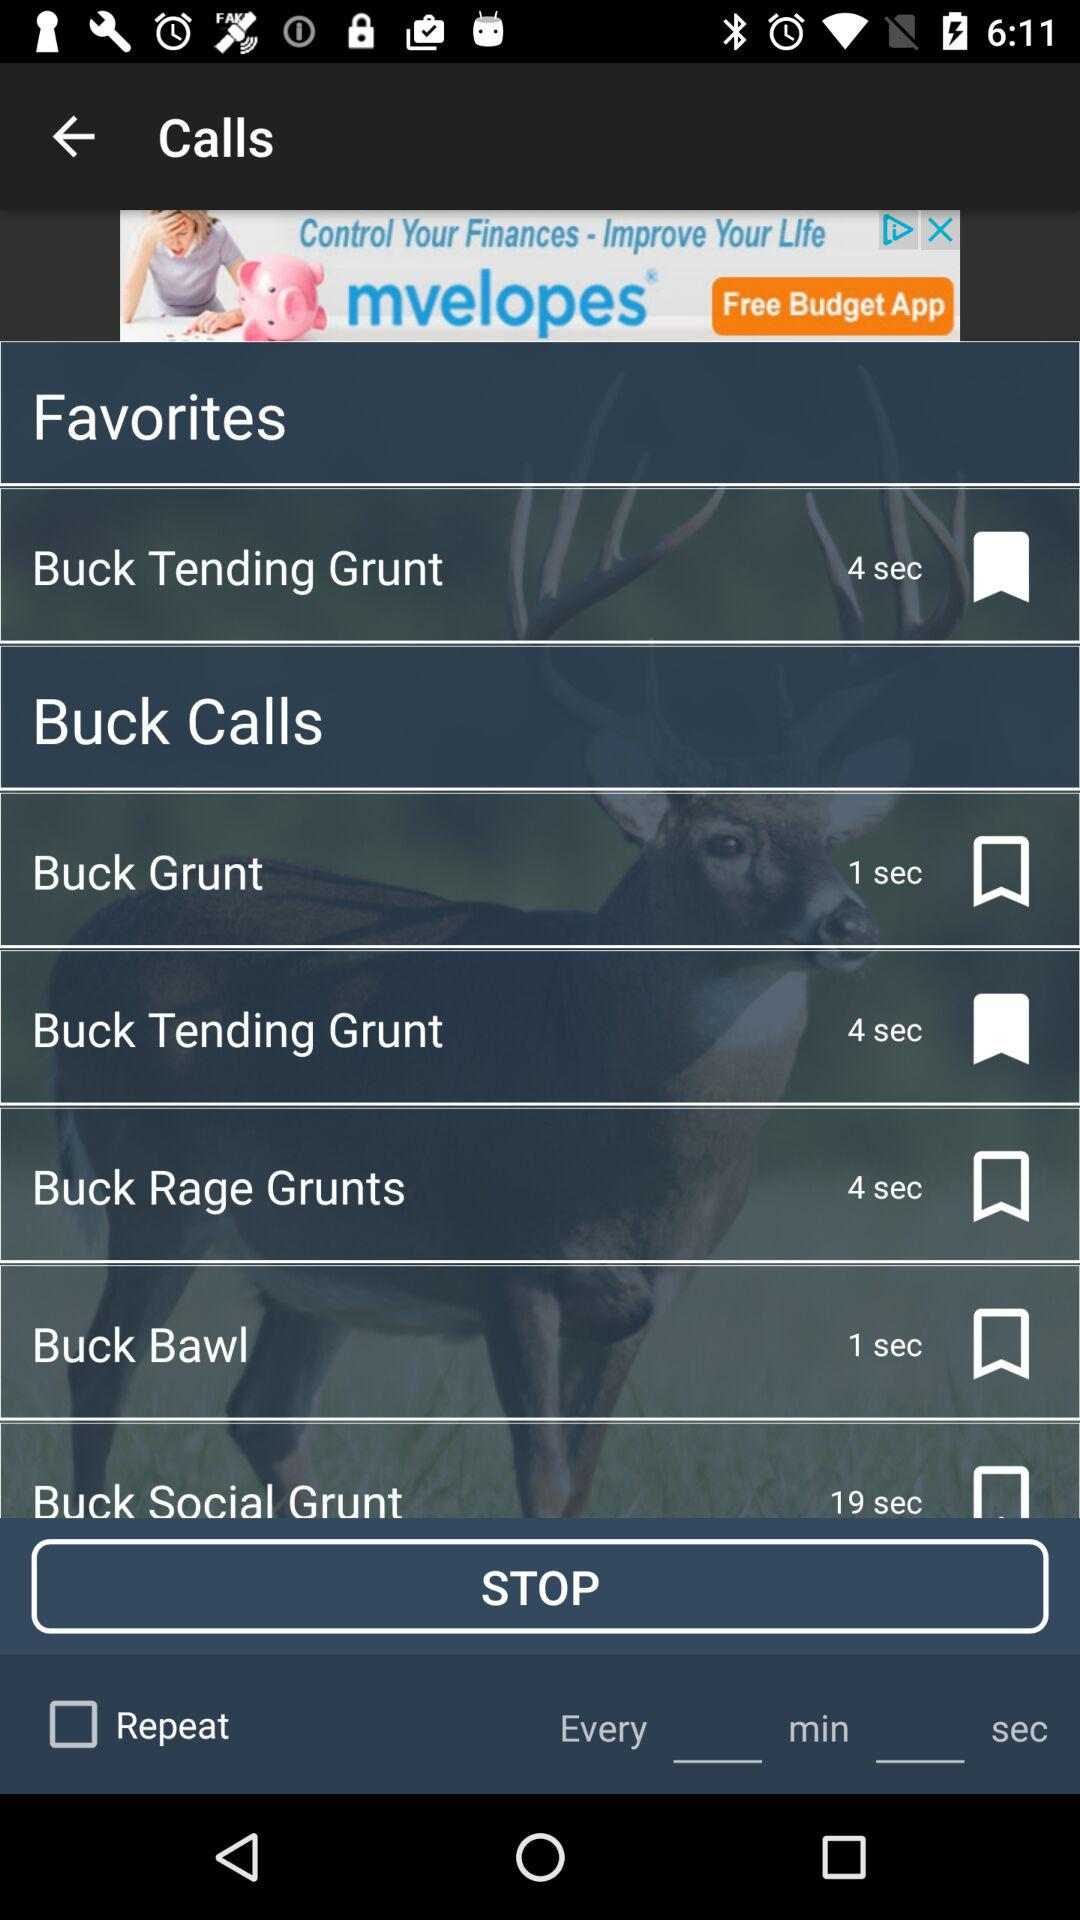What is the duration of "Buck Tending Grunt"? The duration of "Buck Tending Grunt" is 4 seconds. 